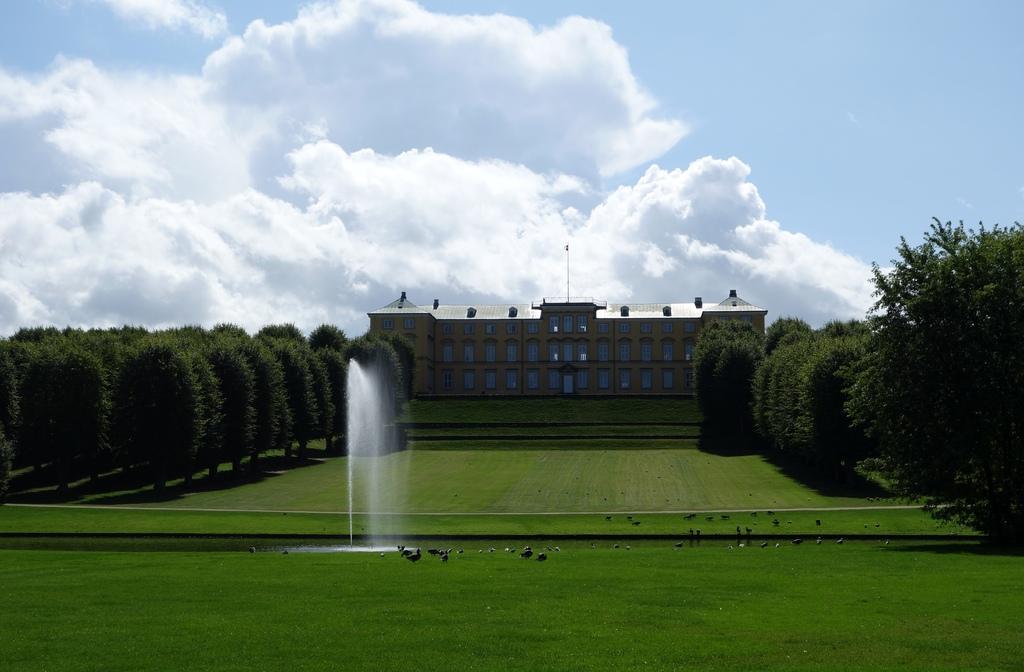Please provide a concise description of this image. In this image we can see a building. There are many trees in the image. There is a grassy land in the image. There is a fountain in the image. We can see the water in the image. There are many birds in the image. We can see the clouds in the sky. 